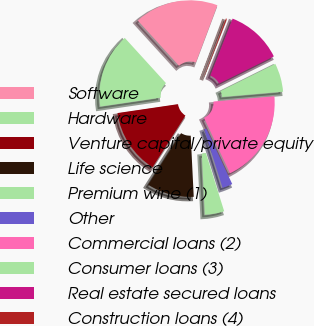<chart> <loc_0><loc_0><loc_500><loc_500><pie_chart><fcel>Software<fcel>Hardware<fcel>Venture capital/private equity<fcel>Life science<fcel>Premium wine (1)<fcel>Other<fcel>Commercial loans (2)<fcel>Consumer loans (3)<fcel>Real estate secured loans<fcel>Construction loans (4)<nl><fcel>17.49%<fcel>15.57%<fcel>13.65%<fcel>9.81%<fcel>4.05%<fcel>2.13%<fcel>19.41%<fcel>5.97%<fcel>11.73%<fcel>0.21%<nl></chart> 